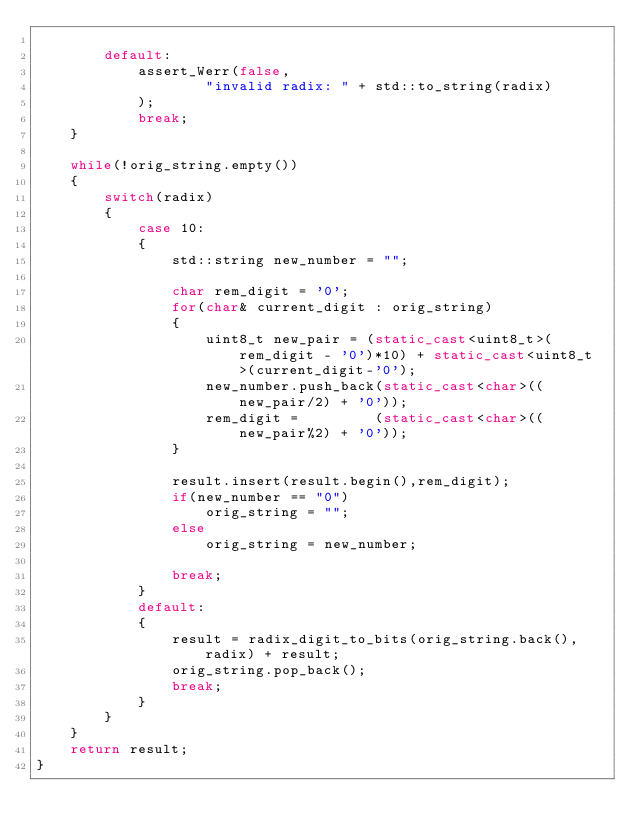Convert code to text. <code><loc_0><loc_0><loc_500><loc_500><_C++_>
		default:	    
            assert_Werr(false, 
                    "invalid radix: " + std::to_string(radix)
            );
            break;
	}

	while(!orig_string.empty())
	{
		switch(radix)
		{
			case 10:
			{
				std::string new_number = "";

				char rem_digit = '0';
				for(char& current_digit : orig_string)
				{
					uint8_t new_pair = (static_cast<uint8_t>(rem_digit - '0')*10) + static_cast<uint8_t>(current_digit-'0');
					new_number.push_back(static_cast<char>((new_pair/2) + '0'));
                    rem_digit =         (static_cast<char>((new_pair%2) + '0'));
				}

                result.insert(result.begin(),rem_digit);
                if(new_number == "0")
                    orig_string = "";
                else
                    orig_string = new_number;

				break;
			}
			default:
			{
                result = radix_digit_to_bits(orig_string.back(), radix) + result;
                orig_string.pop_back();
                break;
			}
		}
	}
	return result;
}
</code> 